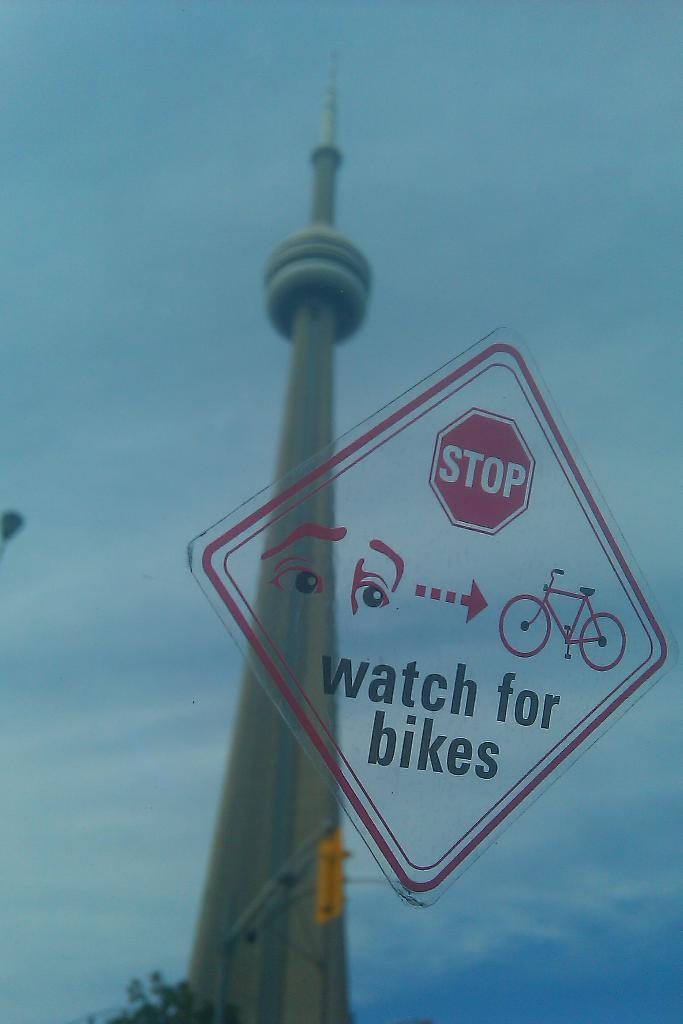<image>
Relay a brief, clear account of the picture shown. In front of a tall, skinny, pointed skyscraper, and stop light is a translucent sign warning drivers to stop and watch for pedestrians on bike. 